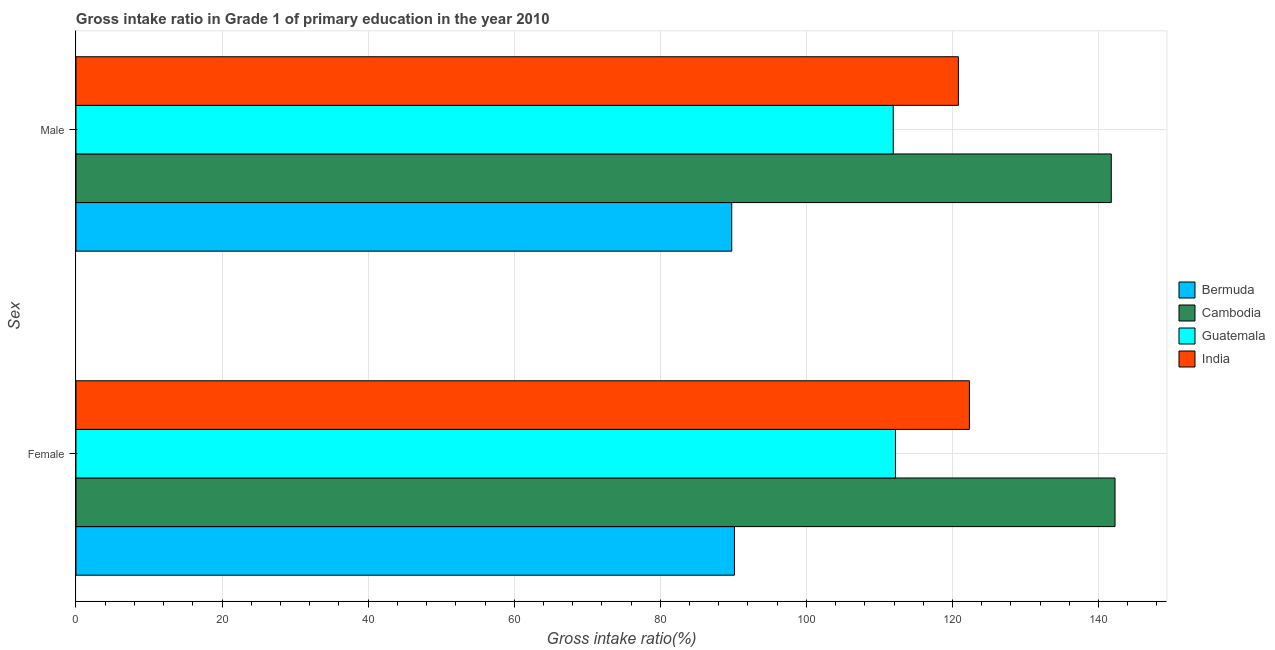How many groups of bars are there?
Offer a terse response. 2. How many bars are there on the 2nd tick from the top?
Ensure brevity in your answer.  4. How many bars are there on the 2nd tick from the bottom?
Offer a very short reply. 4. What is the gross intake ratio(male) in India?
Offer a very short reply. 120.81. Across all countries, what is the maximum gross intake ratio(female)?
Your answer should be compact. 142.26. Across all countries, what is the minimum gross intake ratio(male)?
Give a very brief answer. 89.78. In which country was the gross intake ratio(male) maximum?
Give a very brief answer. Cambodia. In which country was the gross intake ratio(male) minimum?
Your answer should be compact. Bermuda. What is the total gross intake ratio(female) in the graph?
Offer a terse response. 466.92. What is the difference between the gross intake ratio(male) in Cambodia and that in India?
Offer a terse response. 20.93. What is the difference between the gross intake ratio(female) in Cambodia and the gross intake ratio(male) in Guatemala?
Keep it short and to the point. 30.36. What is the average gross intake ratio(female) per country?
Provide a succinct answer. 116.73. What is the difference between the gross intake ratio(female) and gross intake ratio(male) in Guatemala?
Keep it short and to the point. 0.3. In how many countries, is the gross intake ratio(male) greater than 24 %?
Provide a short and direct response. 4. What is the ratio of the gross intake ratio(male) in Guatemala to that in India?
Provide a short and direct response. 0.93. In how many countries, is the gross intake ratio(male) greater than the average gross intake ratio(male) taken over all countries?
Keep it short and to the point. 2. What does the 2nd bar from the top in Female represents?
Keep it short and to the point. Guatemala. What does the 1st bar from the bottom in Male represents?
Your answer should be compact. Bermuda. How many bars are there?
Provide a short and direct response. 8. Are all the bars in the graph horizontal?
Your answer should be very brief. Yes. Are the values on the major ticks of X-axis written in scientific E-notation?
Give a very brief answer. No. Does the graph contain any zero values?
Offer a very short reply. No. Does the graph contain grids?
Keep it short and to the point. Yes. Where does the legend appear in the graph?
Your response must be concise. Center right. How many legend labels are there?
Provide a short and direct response. 4. How are the legend labels stacked?
Provide a succinct answer. Vertical. What is the title of the graph?
Offer a terse response. Gross intake ratio in Grade 1 of primary education in the year 2010. What is the label or title of the X-axis?
Your answer should be compact. Gross intake ratio(%). What is the label or title of the Y-axis?
Provide a short and direct response. Sex. What is the Gross intake ratio(%) in Bermuda in Female?
Ensure brevity in your answer.  90.15. What is the Gross intake ratio(%) of Cambodia in Female?
Give a very brief answer. 142.26. What is the Gross intake ratio(%) of Guatemala in Female?
Give a very brief answer. 112.2. What is the Gross intake ratio(%) in India in Female?
Keep it short and to the point. 122.32. What is the Gross intake ratio(%) of Bermuda in Male?
Provide a short and direct response. 89.78. What is the Gross intake ratio(%) of Cambodia in Male?
Give a very brief answer. 141.75. What is the Gross intake ratio(%) in Guatemala in Male?
Provide a succinct answer. 111.89. What is the Gross intake ratio(%) of India in Male?
Offer a very short reply. 120.81. Across all Sex, what is the maximum Gross intake ratio(%) in Bermuda?
Make the answer very short. 90.15. Across all Sex, what is the maximum Gross intake ratio(%) of Cambodia?
Your answer should be compact. 142.26. Across all Sex, what is the maximum Gross intake ratio(%) of Guatemala?
Your answer should be very brief. 112.2. Across all Sex, what is the maximum Gross intake ratio(%) of India?
Your answer should be compact. 122.32. Across all Sex, what is the minimum Gross intake ratio(%) of Bermuda?
Give a very brief answer. 89.78. Across all Sex, what is the minimum Gross intake ratio(%) of Cambodia?
Keep it short and to the point. 141.75. Across all Sex, what is the minimum Gross intake ratio(%) of Guatemala?
Your answer should be very brief. 111.89. Across all Sex, what is the minimum Gross intake ratio(%) of India?
Make the answer very short. 120.81. What is the total Gross intake ratio(%) in Bermuda in the graph?
Provide a short and direct response. 179.93. What is the total Gross intake ratio(%) of Cambodia in the graph?
Keep it short and to the point. 284. What is the total Gross intake ratio(%) of Guatemala in the graph?
Offer a terse response. 224.09. What is the total Gross intake ratio(%) in India in the graph?
Keep it short and to the point. 243.13. What is the difference between the Gross intake ratio(%) of Bermuda in Female and that in Male?
Make the answer very short. 0.37. What is the difference between the Gross intake ratio(%) of Cambodia in Female and that in Male?
Offer a terse response. 0.51. What is the difference between the Gross intake ratio(%) of Guatemala in Female and that in Male?
Your answer should be compact. 0.3. What is the difference between the Gross intake ratio(%) of India in Female and that in Male?
Give a very brief answer. 1.51. What is the difference between the Gross intake ratio(%) in Bermuda in Female and the Gross intake ratio(%) in Cambodia in Male?
Your answer should be very brief. -51.59. What is the difference between the Gross intake ratio(%) of Bermuda in Female and the Gross intake ratio(%) of Guatemala in Male?
Provide a short and direct response. -21.74. What is the difference between the Gross intake ratio(%) of Bermuda in Female and the Gross intake ratio(%) of India in Male?
Provide a succinct answer. -30.66. What is the difference between the Gross intake ratio(%) of Cambodia in Female and the Gross intake ratio(%) of Guatemala in Male?
Your response must be concise. 30.36. What is the difference between the Gross intake ratio(%) of Cambodia in Female and the Gross intake ratio(%) of India in Male?
Provide a succinct answer. 21.45. What is the difference between the Gross intake ratio(%) in Guatemala in Female and the Gross intake ratio(%) in India in Male?
Your answer should be compact. -8.62. What is the average Gross intake ratio(%) in Bermuda per Sex?
Offer a terse response. 89.97. What is the average Gross intake ratio(%) in Cambodia per Sex?
Provide a succinct answer. 142. What is the average Gross intake ratio(%) of Guatemala per Sex?
Ensure brevity in your answer.  112.04. What is the average Gross intake ratio(%) in India per Sex?
Keep it short and to the point. 121.57. What is the difference between the Gross intake ratio(%) of Bermuda and Gross intake ratio(%) of Cambodia in Female?
Your answer should be very brief. -52.11. What is the difference between the Gross intake ratio(%) in Bermuda and Gross intake ratio(%) in Guatemala in Female?
Your answer should be very brief. -22.04. What is the difference between the Gross intake ratio(%) in Bermuda and Gross intake ratio(%) in India in Female?
Offer a very short reply. -32.17. What is the difference between the Gross intake ratio(%) of Cambodia and Gross intake ratio(%) of Guatemala in Female?
Offer a terse response. 30.06. What is the difference between the Gross intake ratio(%) of Cambodia and Gross intake ratio(%) of India in Female?
Offer a very short reply. 19.94. What is the difference between the Gross intake ratio(%) in Guatemala and Gross intake ratio(%) in India in Female?
Offer a terse response. -10.12. What is the difference between the Gross intake ratio(%) of Bermuda and Gross intake ratio(%) of Cambodia in Male?
Offer a very short reply. -51.96. What is the difference between the Gross intake ratio(%) in Bermuda and Gross intake ratio(%) in Guatemala in Male?
Your response must be concise. -22.11. What is the difference between the Gross intake ratio(%) in Bermuda and Gross intake ratio(%) in India in Male?
Your response must be concise. -31.03. What is the difference between the Gross intake ratio(%) of Cambodia and Gross intake ratio(%) of Guatemala in Male?
Keep it short and to the point. 29.85. What is the difference between the Gross intake ratio(%) of Cambodia and Gross intake ratio(%) of India in Male?
Keep it short and to the point. 20.93. What is the difference between the Gross intake ratio(%) of Guatemala and Gross intake ratio(%) of India in Male?
Offer a very short reply. -8.92. What is the ratio of the Gross intake ratio(%) of Bermuda in Female to that in Male?
Keep it short and to the point. 1. What is the ratio of the Gross intake ratio(%) of Cambodia in Female to that in Male?
Provide a short and direct response. 1. What is the ratio of the Gross intake ratio(%) in India in Female to that in Male?
Your answer should be compact. 1.01. What is the difference between the highest and the second highest Gross intake ratio(%) of Bermuda?
Keep it short and to the point. 0.37. What is the difference between the highest and the second highest Gross intake ratio(%) in Cambodia?
Offer a terse response. 0.51. What is the difference between the highest and the second highest Gross intake ratio(%) in Guatemala?
Your response must be concise. 0.3. What is the difference between the highest and the second highest Gross intake ratio(%) of India?
Offer a terse response. 1.51. What is the difference between the highest and the lowest Gross intake ratio(%) in Bermuda?
Ensure brevity in your answer.  0.37. What is the difference between the highest and the lowest Gross intake ratio(%) in Cambodia?
Provide a succinct answer. 0.51. What is the difference between the highest and the lowest Gross intake ratio(%) of Guatemala?
Your answer should be very brief. 0.3. What is the difference between the highest and the lowest Gross intake ratio(%) of India?
Offer a very short reply. 1.51. 